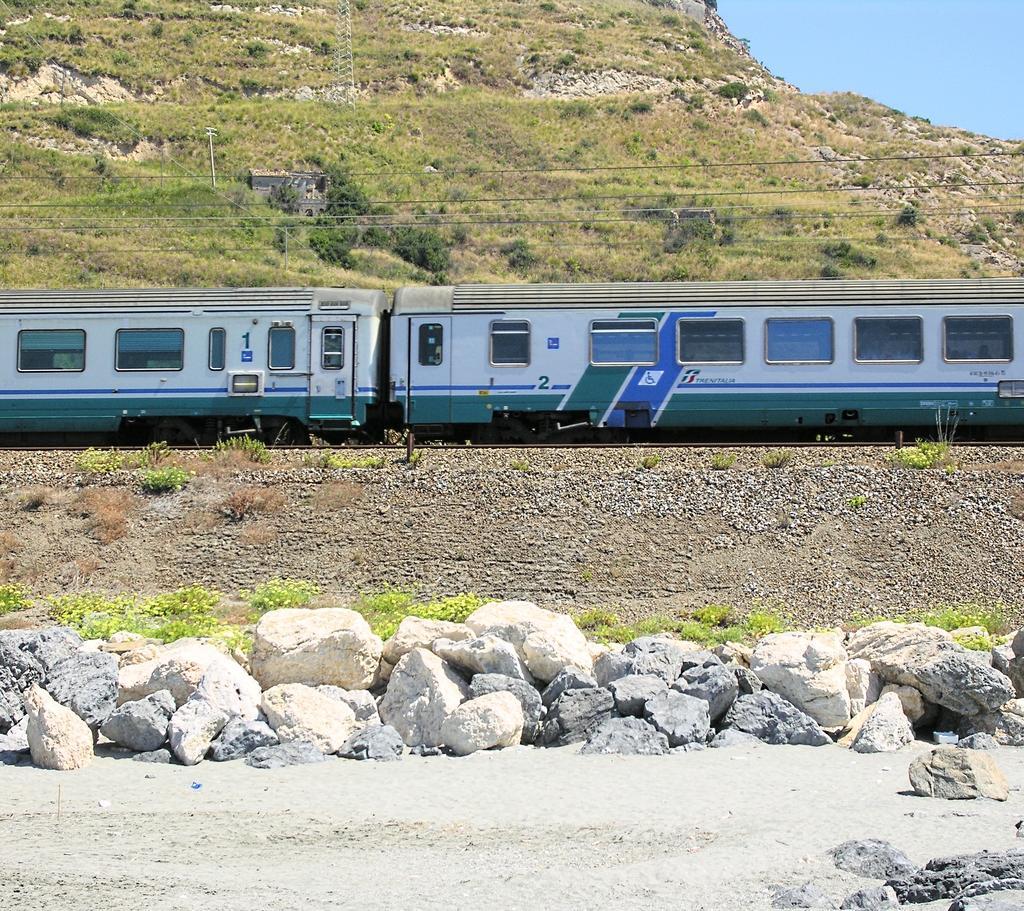How would you summarize this image in a sentence or two? In this picture I can see there are few rocks, soil and there is a train moving on the track and there are few wires, there is a mountain in the backdrop and the sky is clear. 